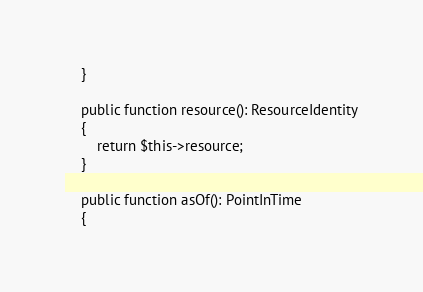<code> <loc_0><loc_0><loc_500><loc_500><_PHP_>    }

    public function resource(): ResourceIdentity
    {
        return $this->resource;
    }

    public function asOf(): PointInTime
    {</code> 